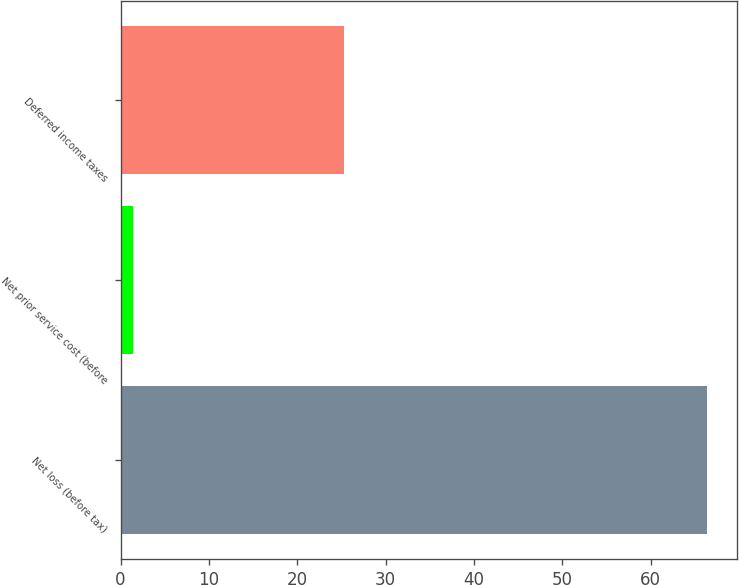<chart> <loc_0><loc_0><loc_500><loc_500><bar_chart><fcel>Net loss (before tax)<fcel>Net prior service cost (before<fcel>Deferred income taxes<nl><fcel>66.4<fcel>1.4<fcel>25.3<nl></chart> 